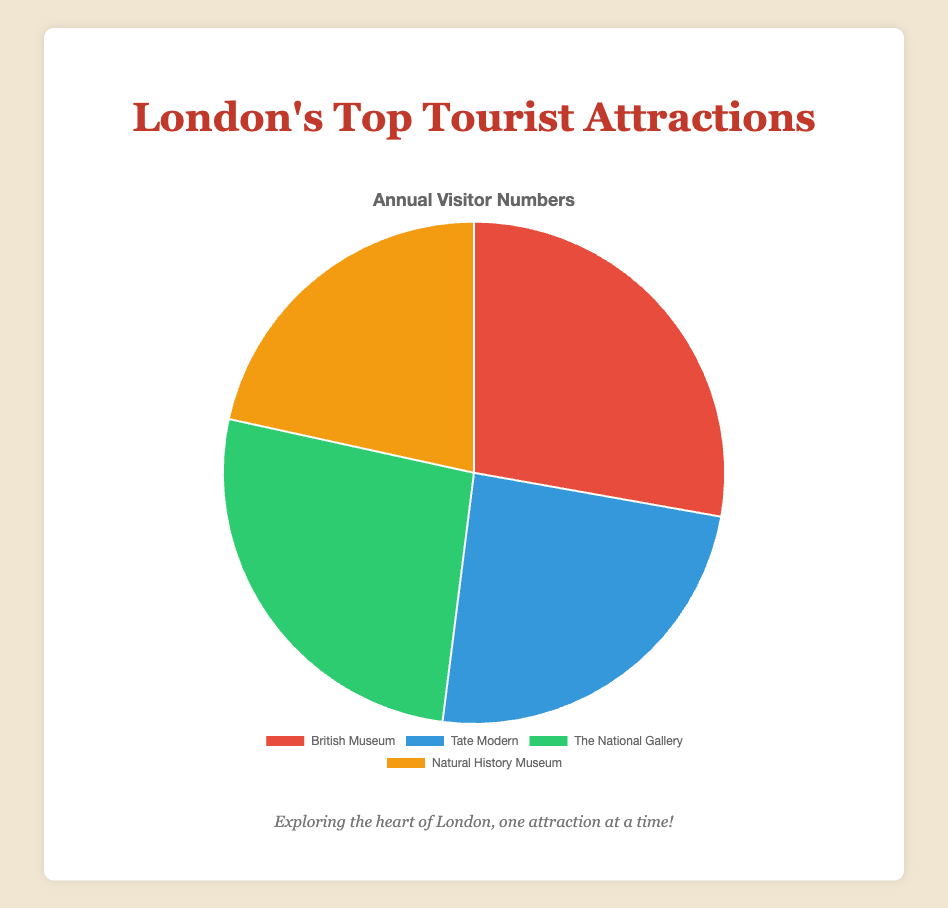Which tourist attraction has the highest number of visitors? From the pie chart, the highest number of visitor numbers is indicated for the British Museum.
Answer: British Museum Which tourist attraction has the fewest number of visitors? From the pie chart, the lowest number of visitor numbers is shown for the Natural History Museum.
Answer: Natural History Museum How many more visitors does the British Museum have compared to Tate Modern? The British Museum has 6,730,000 visitors and Tate Modern has 5,860,000 visitors. The difference is 6,730,000 - 5,860,000 = 870,000.
Answer: 870,000 What are the combined visitor numbers for the British Museum and The National Gallery? Adding the visitor numbers for the British Museum (6,730,000) and The National Gallery (6,400,000) gives a total of 13,130,000.
Answer: 13,130,000 What percentage of the total visitors does the Natural History Museum receive? First, find the total visitors: 6,730,000 (British Museum) + 5,860,000 (Tate Modern) + 6,400,000 (The National Gallery) + 5,220,000 (Natural History Museum) = 24,210,000. Then, calculate the percentage: (5,220,000 / 24,210,000) * 100 ≈ 21.6%.
Answer: 21.6% How many fewer visitors does Natural History Museum have compared to The National Gallery? The Natural History Museum has 5,220,000 visitors, while The National Gallery has 6,400,000. The difference is 6,400,000 - 5,220,000 = 1,180,000.
Answer: 1,180,000 What is the average number of visitors across all four attractions? Sum the visitor numbers: 6,730,000 (British Museum) + 5,860,000 (Tate Modern) + 6,400,000 (The National Gallery) + 5,220,000 (Natural History Museum) = 24,210,000. Then divide by 4: 24,210,000 / 4 = 6,052,500.
Answer: 6,052,500 Which attraction is represented by the blue slice in the pie chart? The pie chart's blue slice corresponds to Tate Modern based on the typical colors used.
Answer: Tate Modern What is the total number of visitors for all four attractions combined? Add the visitor numbers: 6,730,000 + 5,860,000 + 6,400,000 + 5,220,000 = 24,210,000.
Answer: 24,210,000 Which attraction receives more visitors, The National Gallery or Tate Modern? By comparing the visitor numbers, The National Gallery (6,400,000) has more visitors than Tate Modern (5,860,000).
Answer: The National Gallery 